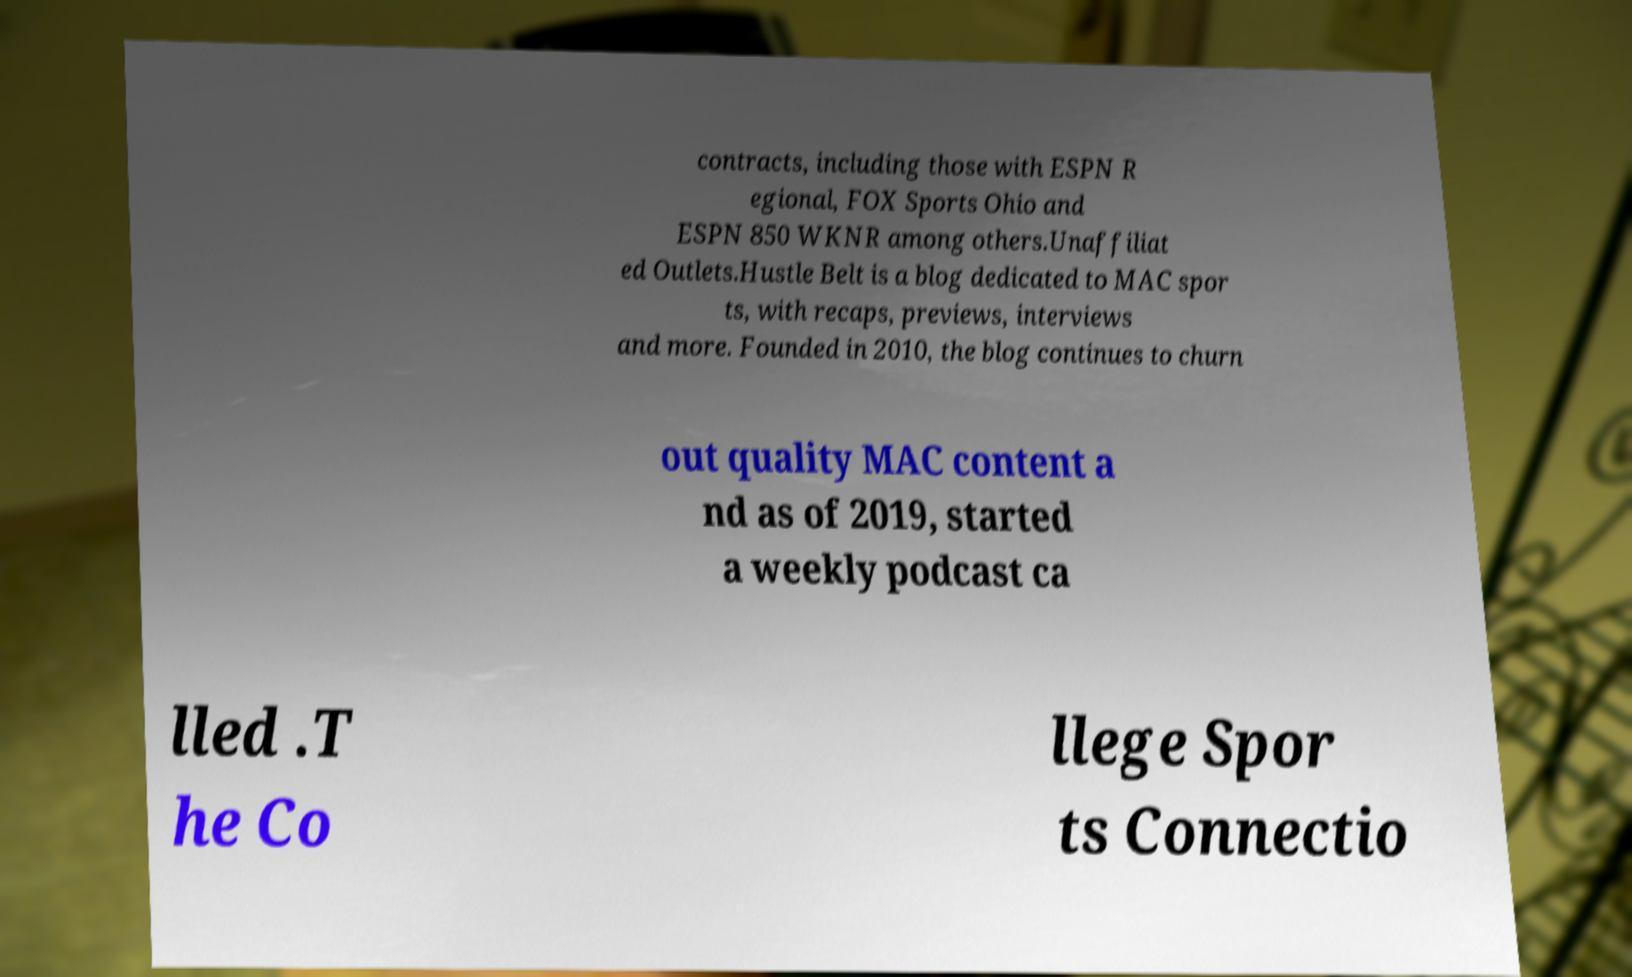I need the written content from this picture converted into text. Can you do that? contracts, including those with ESPN R egional, FOX Sports Ohio and ESPN 850 WKNR among others.Unaffiliat ed Outlets.Hustle Belt is a blog dedicated to MAC spor ts, with recaps, previews, interviews and more. Founded in 2010, the blog continues to churn out quality MAC content a nd as of 2019, started a weekly podcast ca lled .T he Co llege Spor ts Connectio 